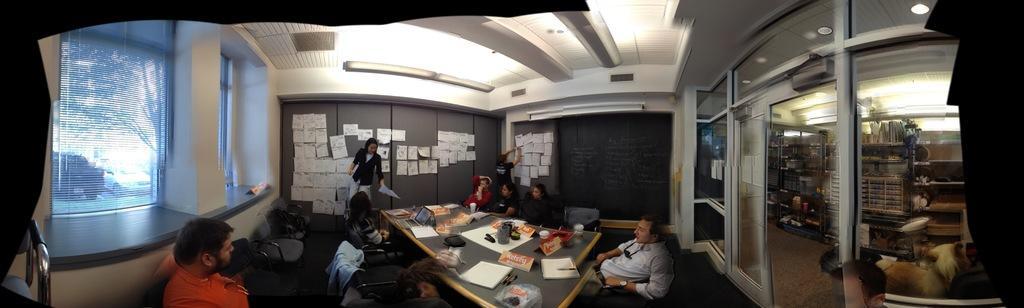Describe this image in one or two sentences. We can see posts over a wall. At the top we can see ceiling and lights. This is AC ducts. We can see windows here. We can see persons sitting on chairs in front of a table. We can see two persons standing on the floor. This is a door. We can see desks, lockers here. On the table we can see papers, pens, boards, device, glasses. 